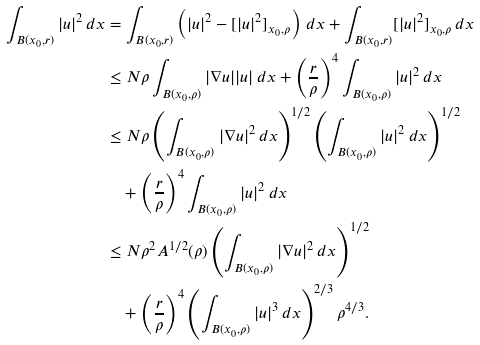<formula> <loc_0><loc_0><loc_500><loc_500>\int _ { B ( x _ { 0 } , r ) } | u | ^ { 2 } \, d x & = \int _ { B ( x _ { 0 } , r ) } \left ( | u | ^ { 2 } - [ | u | ^ { 2 } ] _ { x _ { 0 } , \rho } \right ) \, d x + \int _ { B ( x _ { 0 } , r ) } [ | u | ^ { 2 } ] _ { x _ { 0 } , \rho } \, d x \\ & \leq N \rho \int _ { B ( x _ { 0 } , \rho ) } | \nabla u | | u | \, d x + \left ( \frac { r } { \rho } \right ) ^ { 4 } \int _ { B ( x _ { 0 } , \rho ) } | u | ^ { 2 } \, d x \\ & \leq N \rho \left ( \int _ { B ( x _ { 0 } , \rho ) } | \nabla u | ^ { 2 } \, d x \right ) ^ { 1 / 2 } \left ( \int _ { B ( x _ { 0 } , \rho ) } | u | ^ { 2 } \, d x \right ) ^ { 1 / 2 } \\ & \quad + \left ( \frac { r } { \rho } \right ) ^ { 4 } \int _ { B ( x _ { 0 } , \rho ) } | u | ^ { 2 } \, d x \\ & \leq N \rho ^ { 2 } A ^ { 1 / 2 } ( \rho ) \left ( \int _ { B ( x _ { 0 } , \rho ) } | \nabla u | ^ { 2 } \, d x \right ) ^ { 1 / 2 } \\ & \quad + \left ( \frac { r } { \rho } \right ) ^ { 4 } \left ( \int _ { B ( x _ { 0 } , \rho ) } | u | ^ { 3 } \, d x \right ) ^ { 2 / 3 } \rho ^ { 4 / 3 } .</formula> 